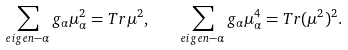Convert formula to latex. <formula><loc_0><loc_0><loc_500><loc_500>\sum _ { e i g e n - \alpha } g _ { \alpha } \mu ^ { 2 } _ { \alpha } = { T r } \mu ^ { 2 } , \quad \sum _ { e i g e n - \alpha } g _ { \alpha } \mu ^ { 4 } _ { \alpha } = { T r } ( \mu ^ { 2 } ) ^ { 2 } .</formula> 